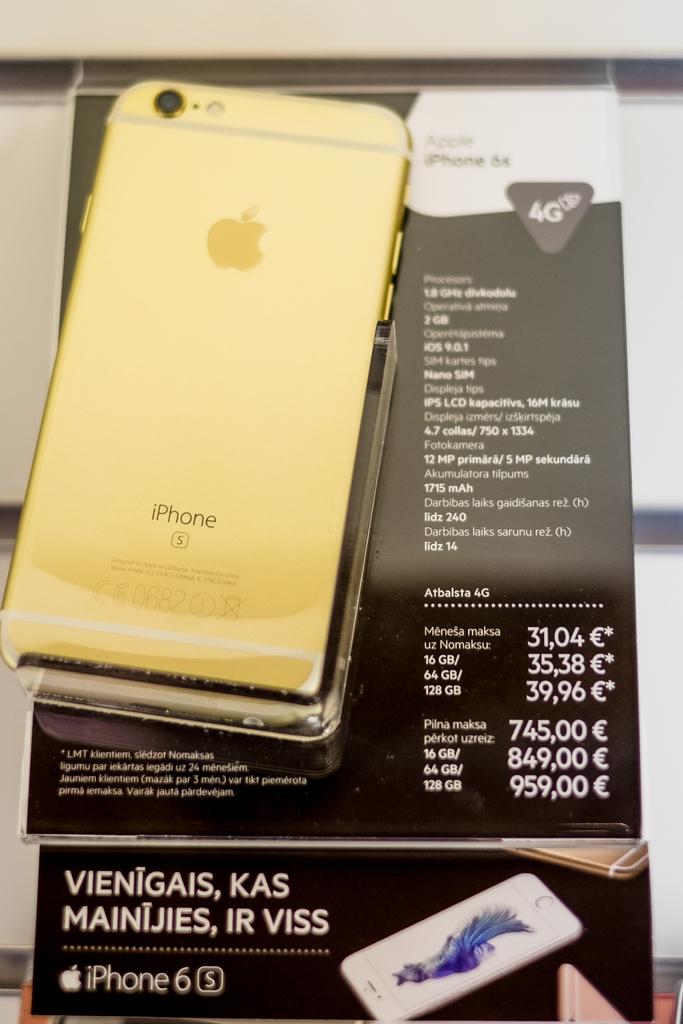Is this phone information?
Your answer should be compact. Yes. What brand of phone is this?
Provide a succinct answer. Iphone. 